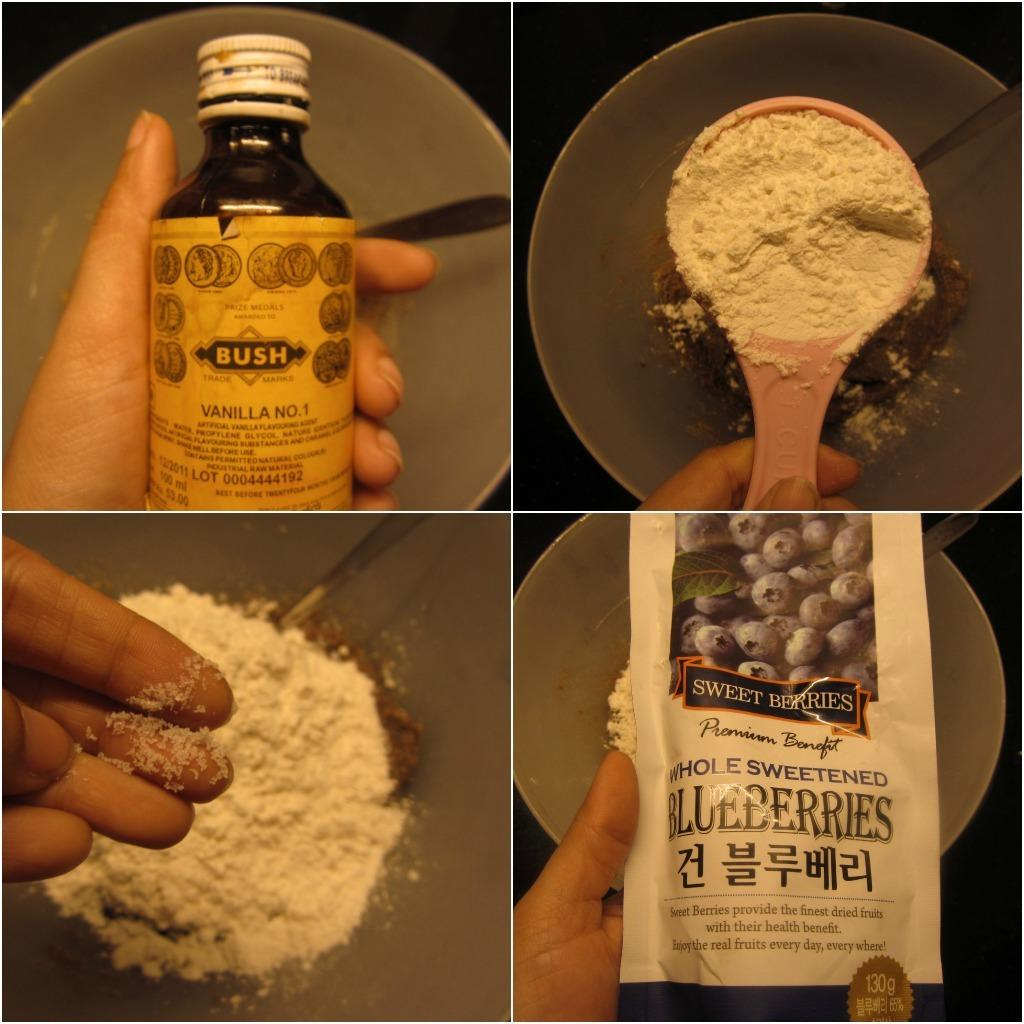<image>
Render a clear and concise summary of the photo. Blueberries in a package are labeled as whole and sweetened. 